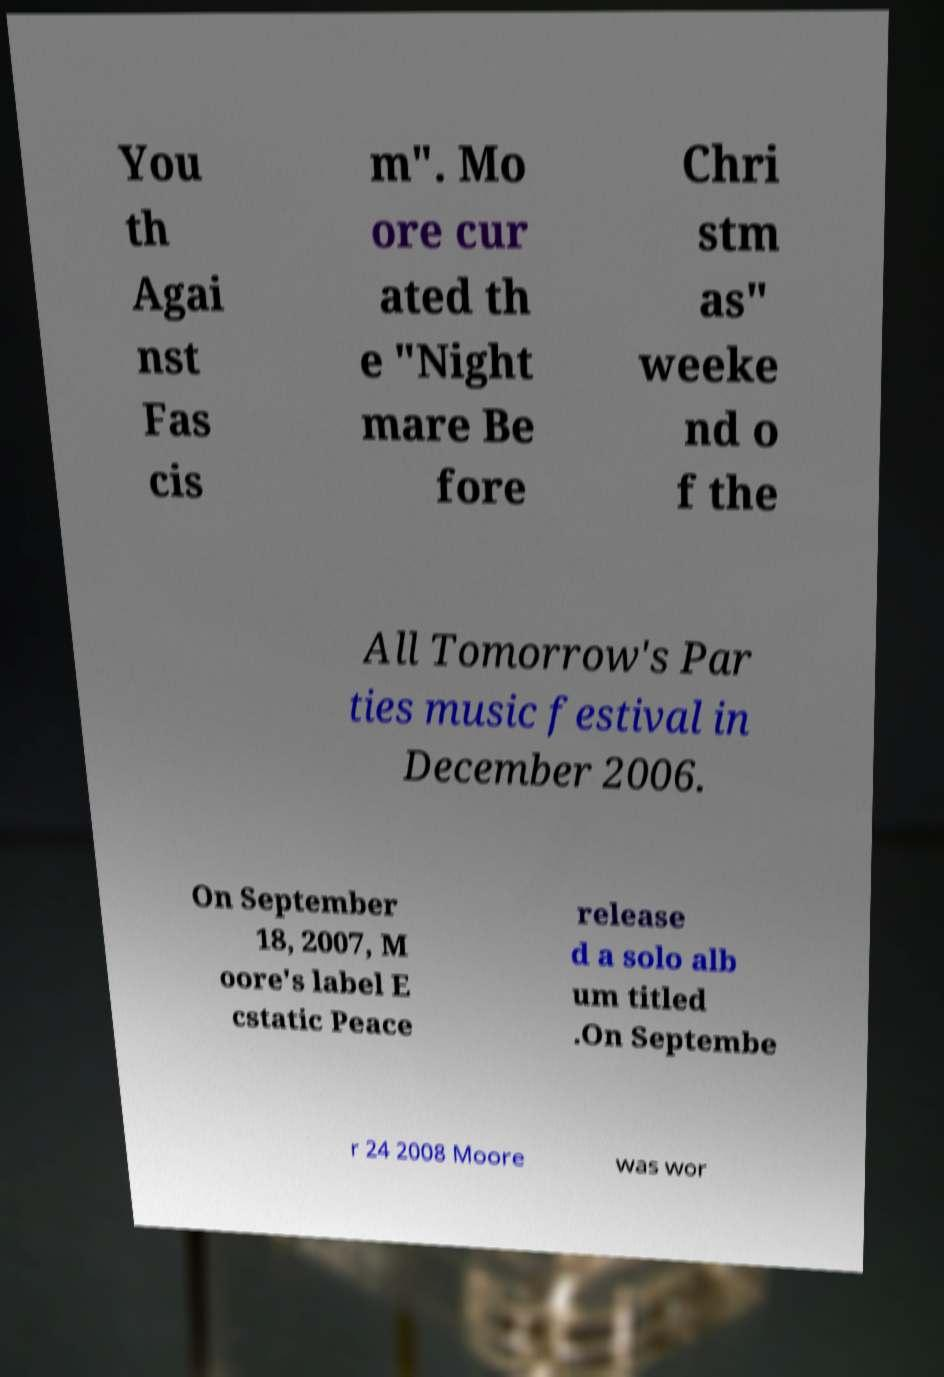Could you extract and type out the text from this image? You th Agai nst Fas cis m". Mo ore cur ated th e "Night mare Be fore Chri stm as" weeke nd o f the All Tomorrow's Par ties music festival in December 2006. On September 18, 2007, M oore's label E cstatic Peace release d a solo alb um titled .On Septembe r 24 2008 Moore was wor 